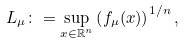<formula> <loc_0><loc_0><loc_500><loc_500>L _ { \mu } \colon = \sup _ { x \in { \mathbb { R } } ^ { n } } \left ( f _ { \mu } ( x ) \right ) ^ { 1 / n } ,</formula> 